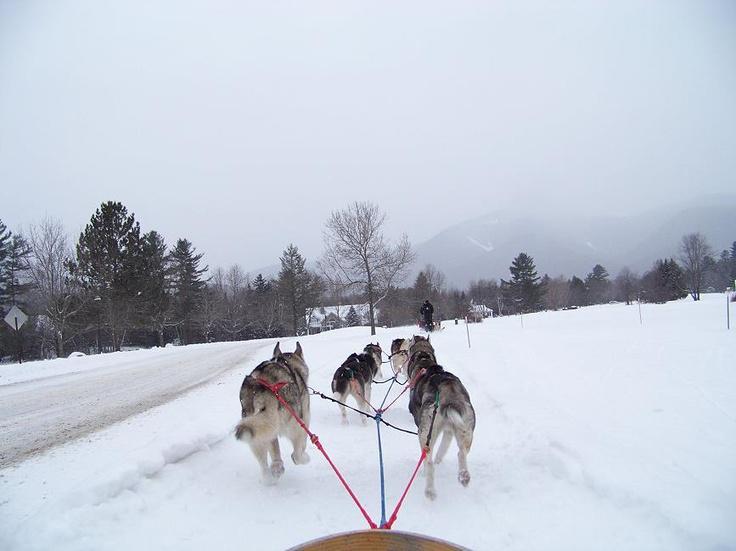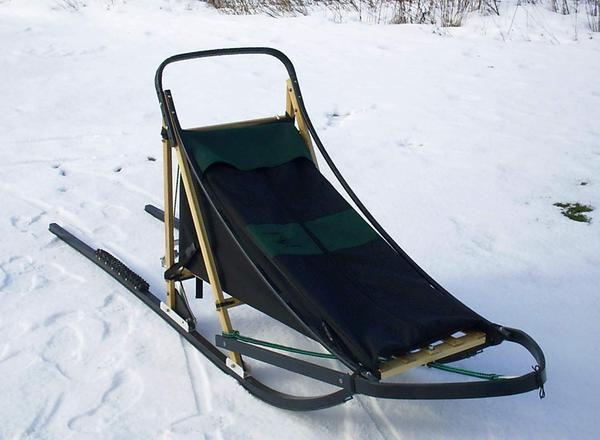The first image is the image on the left, the second image is the image on the right. For the images shown, is this caption "The sled on the snow in one of the images is empty." true? Answer yes or no. Yes. The first image is the image on the left, the second image is the image on the right. Considering the images on both sides, is "At least one image shows a sled dog team headed straight, away from the camera." valid? Answer yes or no. Yes. 